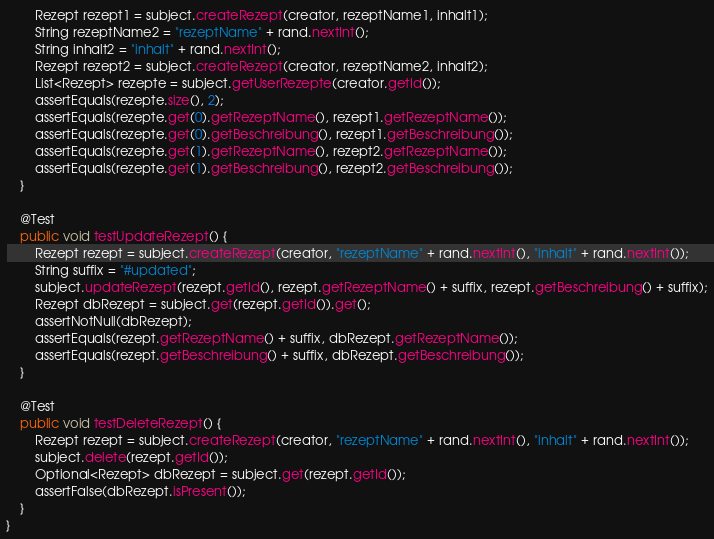<code> <loc_0><loc_0><loc_500><loc_500><_Java_>        Rezept rezept1 = subject.createRezept(creator, rezeptName1, inhalt1);
        String rezeptName2 = "rezeptName" + rand.nextInt();
        String inhalt2 = "inhalt" + rand.nextInt();
        Rezept rezept2 = subject.createRezept(creator, rezeptName2, inhalt2);
        List<Rezept> rezepte = subject.getUserRezepte(creator.getId());
        assertEquals(rezepte.size(), 2);
        assertEquals(rezepte.get(0).getRezeptName(), rezept1.getRezeptName());
        assertEquals(rezepte.get(0).getBeschreibung(), rezept1.getBeschreibung());
        assertEquals(rezepte.get(1).getRezeptName(), rezept2.getRezeptName());
        assertEquals(rezepte.get(1).getBeschreibung(), rezept2.getBeschreibung());
    }

    @Test
    public void testUpdateRezept() {
        Rezept rezept = subject.createRezept(creator, "rezeptName" + rand.nextInt(), "inhalt" + rand.nextInt());
        String suffix = "#updated";
        subject.updateRezept(rezept.getId(), rezept.getRezeptName() + suffix, rezept.getBeschreibung() + suffix);
        Rezept dbRezept = subject.get(rezept.getId()).get();
        assertNotNull(dbRezept);
        assertEquals(rezept.getRezeptName() + suffix, dbRezept.getRezeptName());
        assertEquals(rezept.getBeschreibung() + suffix, dbRezept.getBeschreibung());
    }

    @Test
    public void testDeleteRezept() {
        Rezept rezept = subject.createRezept(creator, "rezeptName" + rand.nextInt(), "inhalt" + rand.nextInt());
        subject.delete(rezept.getId());
        Optional<Rezept> dbRezept = subject.get(rezept.getId());
        assertFalse(dbRezept.isPresent());
    }
}
</code> 